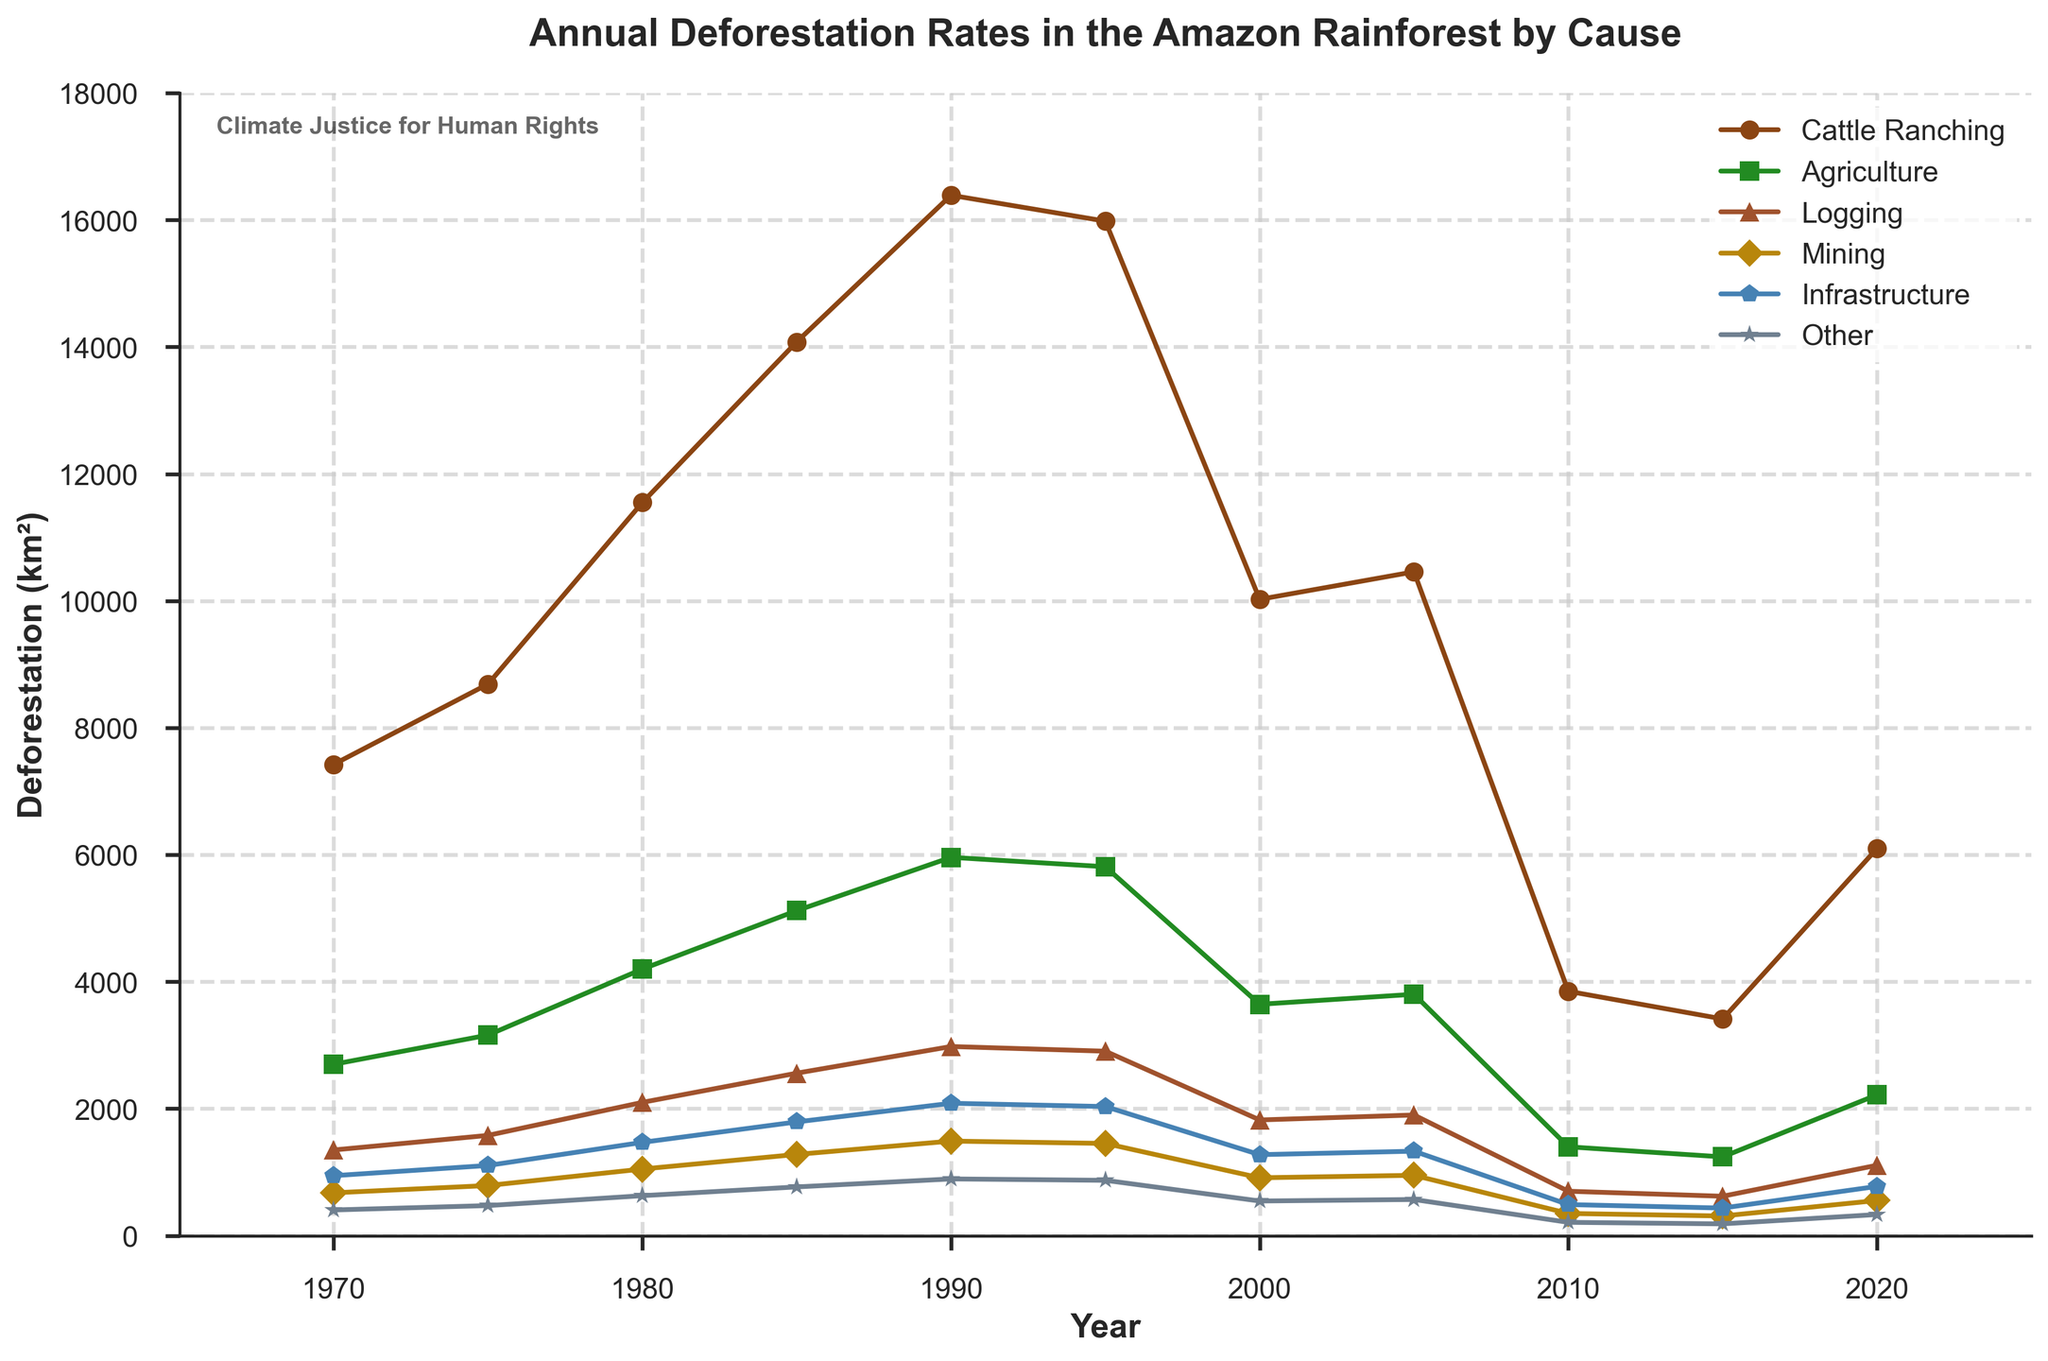What is the primary cause of deforestation in the Amazon rainforest from 1970 to 2020? By observing the data, the line representing Cattle Ranching is consistently the highest among all causes from 1970 to 2020.
Answer: Cattle Ranching When did the deforestation rate due to agriculture peak, and what was the rate? The peak in agriculture-related deforestation occurs in 1990 where the value on the y-axis for Agriculture is highest, reaching 5960 km².
Answer: 1990, 5960 km² How does the total deforestation rate in 2010 compare to that in 1980? From the data, the total deforestation in 1980 was 21000 km², and in 2010 it was 7000 km², showing a decrease of 14000 km².
Answer: The rate decreased by 14000 km² In what year did mining contribute the least to deforestation, and what was the rate? The smallest value for Mining is found in 2015, where the rate is 310 km².
Answer: 2015, 310 km² Which two causes had the closest deforestation rates in 2000, and what were those rates? In 2000, comparing the y-values, Logging (1823 km²) and Mining (912 km²) were relatively close.
Answer: Logging (1823 km²) and Mining (912 km²) What is the average annual deforestation rate due to Logging from 1970 to 2020? Sum the logging rates for all years: 1350 + 1580 + 2100 + 2560 + 2980 + 2906 + 1823 + 1901 + 700 + 621 + 1109 = 18930. Divide by the number of years: 18930/11 ≈ 1721 km².
Answer: 1721 km² Compare the deforestation rates due to Infrastructure in 1970 and 2020. By how much did it change? The rate in 1970 was 945 km² and 776 km² in 2020. Subtracting these gives 945 - 776 = 169 km².
Answer: The rate decreased by 169 km² Which year saw the highest total deforestation rate, and what was the rate? The highest total deforestation occurs in 1990, where the rate reaches 29800 km².
Answer: 1990, 29800 km² How did deforestation caused by Other factors change from 1985 to 2015? In 1985, the rate was 768 km², and in 2015 it was 186 km². The change is 768 - 186 = 582 km².
Answer: It decreased by 582 km² In which year did Agriculture cause more deforestation than Logging, and by how much more? In 1990, Agriculture caused 5960 km² and Logging caused 2980 km². The difference is 5960 - 2980 = 2980 km².
Answer: In 1990, by 2980 km² 